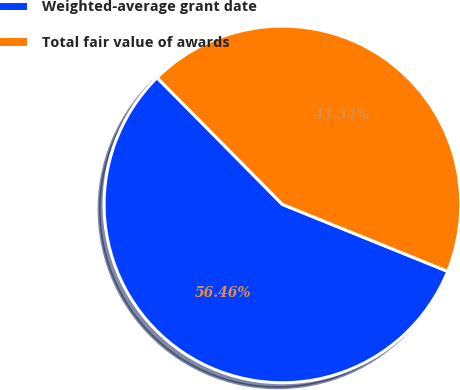<chart> <loc_0><loc_0><loc_500><loc_500><pie_chart><fcel>Weighted-average grant date<fcel>Total fair value of awards<nl><fcel>56.46%<fcel>43.54%<nl></chart> 